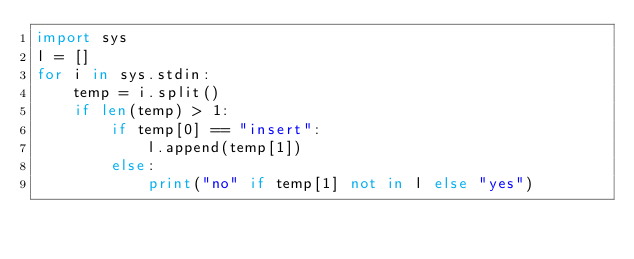Convert code to text. <code><loc_0><loc_0><loc_500><loc_500><_Python_>import sys
l = []
for i in sys.stdin:
    temp = i.split()
    if len(temp) > 1:
        if temp[0] == "insert":
            l.append(temp[1])
        else:
            print("no" if temp[1] not in l else "yes")
</code> 